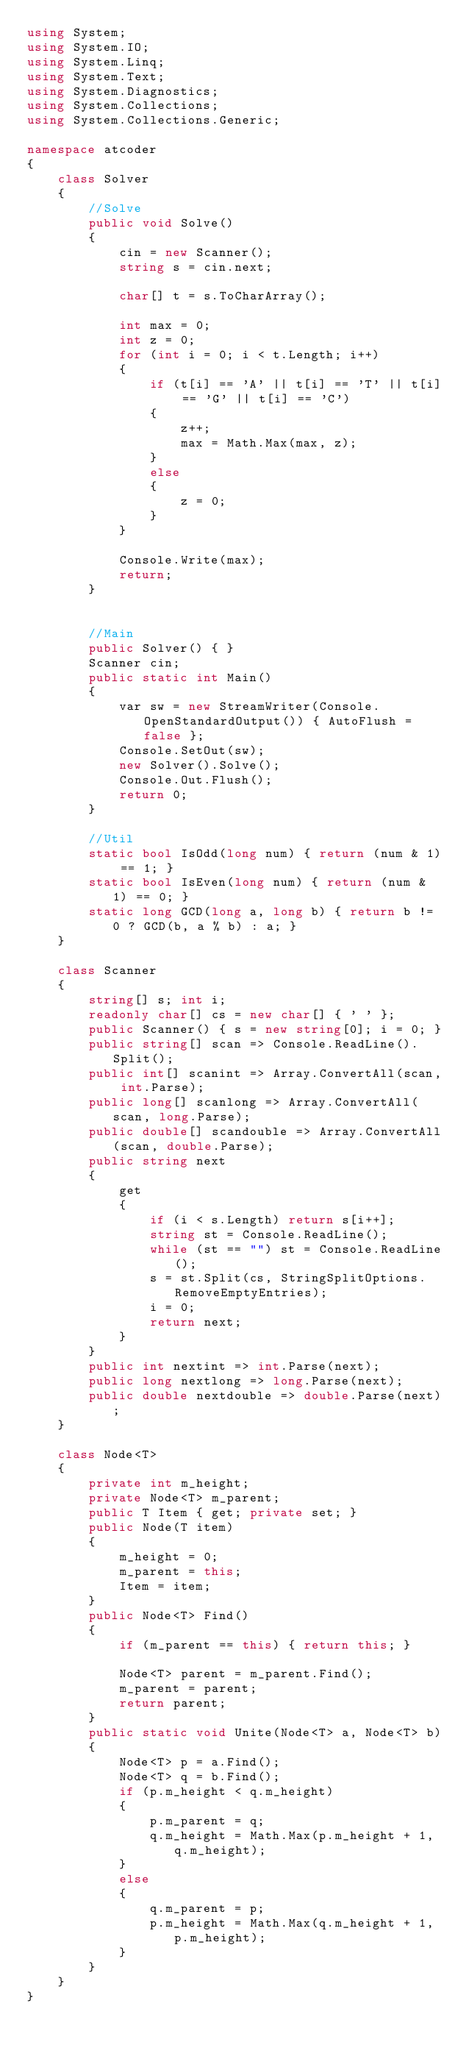Convert code to text. <code><loc_0><loc_0><loc_500><loc_500><_C#_>using System;
using System.IO;
using System.Linq;
using System.Text;
using System.Diagnostics;
using System.Collections;
using System.Collections.Generic;

namespace atcoder
{
    class Solver
    {
        //Solve
        public void Solve()
        {
            cin = new Scanner();
            string s = cin.next;

            char[] t = s.ToCharArray();

            int max = 0;
            int z = 0;
            for (int i = 0; i < t.Length; i++)
            {
                if (t[i] == 'A' || t[i] == 'T' || t[i] == 'G' || t[i] == 'C')
                {
                    z++;
                    max = Math.Max(max, z);
                }
                else
                {
                    z = 0;
                }
            }

            Console.Write(max);
            return;
        }


        //Main
        public Solver() { }
        Scanner cin;
        public static int Main()
        {
            var sw = new StreamWriter(Console.OpenStandardOutput()) { AutoFlush = false };
            Console.SetOut(sw);
            new Solver().Solve();
            Console.Out.Flush();
            return 0;
        }

        //Util
        static bool IsOdd(long num) { return (num & 1) == 1; }
        static bool IsEven(long num) { return (num & 1) == 0; }
        static long GCD(long a, long b) { return b != 0 ? GCD(b, a % b) : a; }
    }

    class Scanner
    {
        string[] s; int i;
        readonly char[] cs = new char[] { ' ' };
        public Scanner() { s = new string[0]; i = 0; }
        public string[] scan => Console.ReadLine().Split();
        public int[] scanint => Array.ConvertAll(scan, int.Parse);
        public long[] scanlong => Array.ConvertAll(scan, long.Parse);
        public double[] scandouble => Array.ConvertAll(scan, double.Parse);
        public string next
        {
            get
            {
                if (i < s.Length) return s[i++];
                string st = Console.ReadLine();
                while (st == "") st = Console.ReadLine();
                s = st.Split(cs, StringSplitOptions.RemoveEmptyEntries);
                i = 0;
                return next;
            }
        }
        public int nextint => int.Parse(next);
        public long nextlong => long.Parse(next);
        public double nextdouble => double.Parse(next);
    }

    class Node<T>
    {
        private int m_height;
        private Node<T> m_parent;
        public T Item { get; private set; }
        public Node(T item)
        {
            m_height = 0;
            m_parent = this;
            Item = item;
        }
        public Node<T> Find()
        {
            if (m_parent == this) { return this; }

            Node<T> parent = m_parent.Find();
            m_parent = parent;
            return parent;
        }
        public static void Unite(Node<T> a, Node<T> b)
        {
            Node<T> p = a.Find();
            Node<T> q = b.Find();
            if (p.m_height < q.m_height)
            {
                p.m_parent = q;
                q.m_height = Math.Max(p.m_height + 1, q.m_height);
            }
            else
            {
                q.m_parent = p;
                p.m_height = Math.Max(q.m_height + 1, p.m_height);
            }
        }
    }
}</code> 